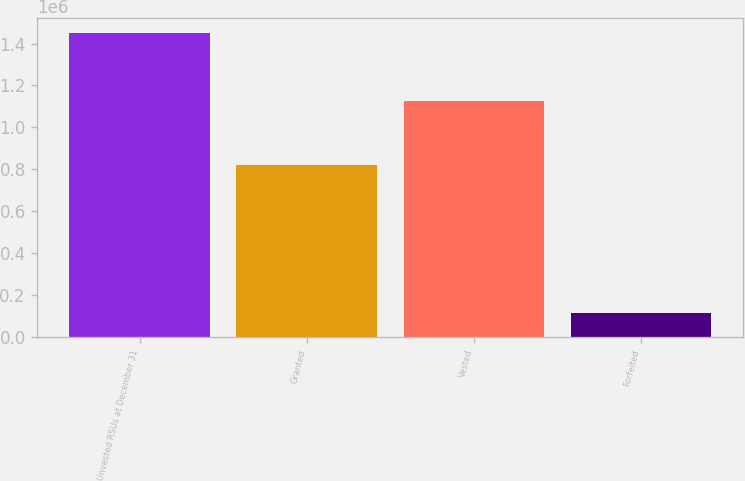Convert chart to OTSL. <chart><loc_0><loc_0><loc_500><loc_500><bar_chart><fcel>Unvested RSUs at December 31<fcel>Granted<fcel>Vested<fcel>Forfeited<nl><fcel>1.44824e+06<fcel>822117<fcel>1.12438e+06<fcel>112216<nl></chart> 